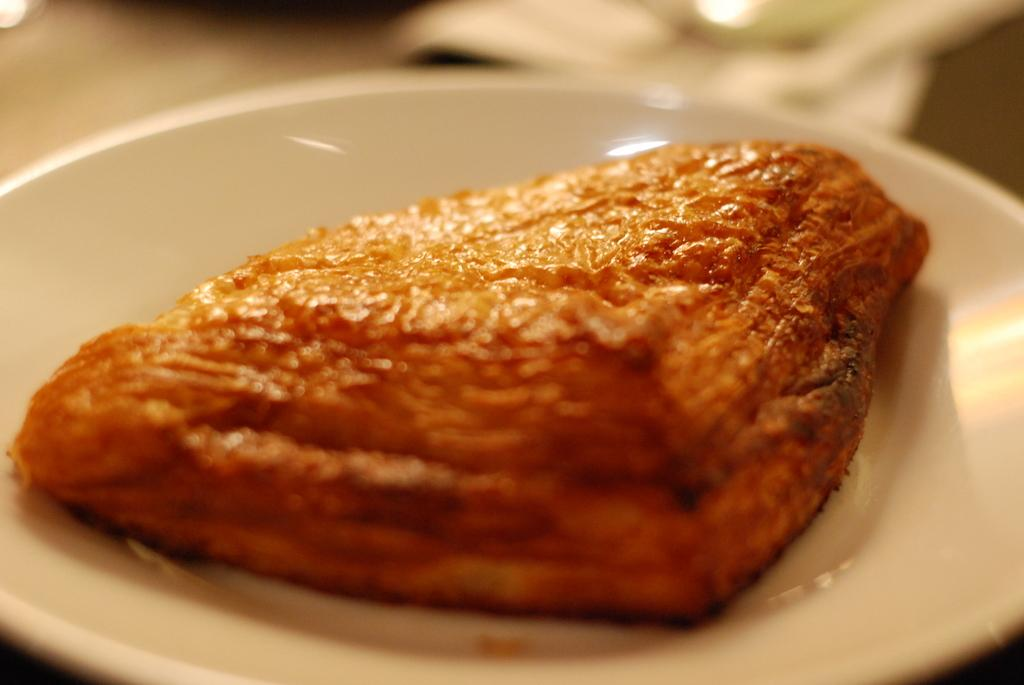What is present on the serving plate in the image? The serving plate has a baked item in it. Can you describe the baked item on the plate? Unfortunately, the specific type of baked item cannot be determined from the image alone. What type of grass is growing on the list in the image? There is no grass or list present in the image. 